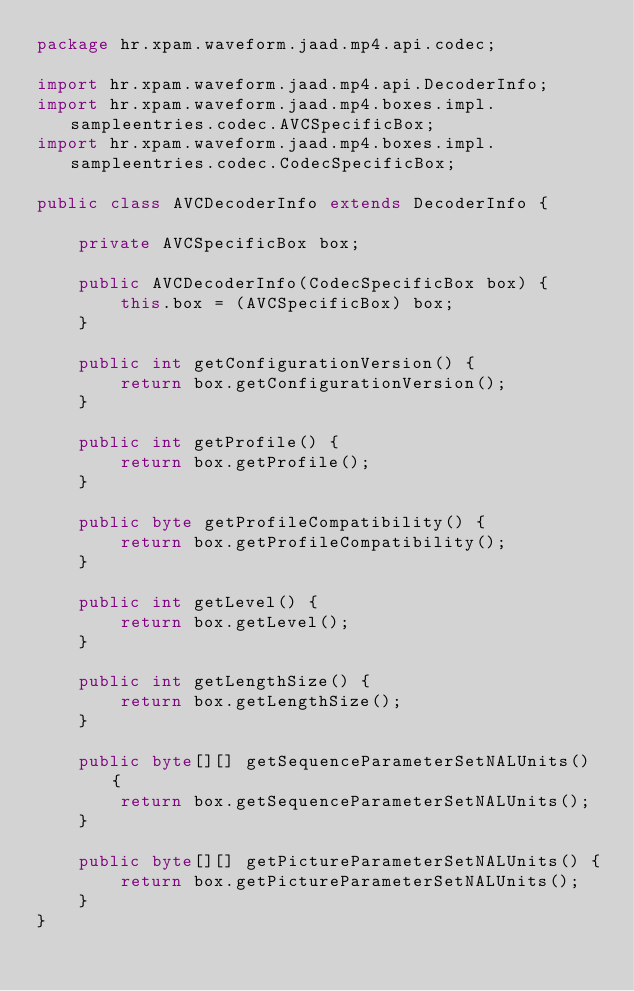<code> <loc_0><loc_0><loc_500><loc_500><_Java_>package hr.xpam.waveform.jaad.mp4.api.codec;

import hr.xpam.waveform.jaad.mp4.api.DecoderInfo;
import hr.xpam.waveform.jaad.mp4.boxes.impl.sampleentries.codec.AVCSpecificBox;
import hr.xpam.waveform.jaad.mp4.boxes.impl.sampleentries.codec.CodecSpecificBox;

public class AVCDecoderInfo extends DecoderInfo {

	private AVCSpecificBox box;

	public AVCDecoderInfo(CodecSpecificBox box) {
		this.box = (AVCSpecificBox) box;
	}

	public int getConfigurationVersion() {
		return box.getConfigurationVersion();
	}

	public int getProfile() {
		return box.getProfile();
	}

	public byte getProfileCompatibility() {
		return box.getProfileCompatibility();
	}

	public int getLevel() {
		return box.getLevel();
	}

	public int getLengthSize() {
		return box.getLengthSize();
	}

	public byte[][] getSequenceParameterSetNALUnits() {
		return box.getSequenceParameterSetNALUnits();
	}

	public byte[][] getPictureParameterSetNALUnits() {
		return box.getPictureParameterSetNALUnits();
	}
}
</code> 